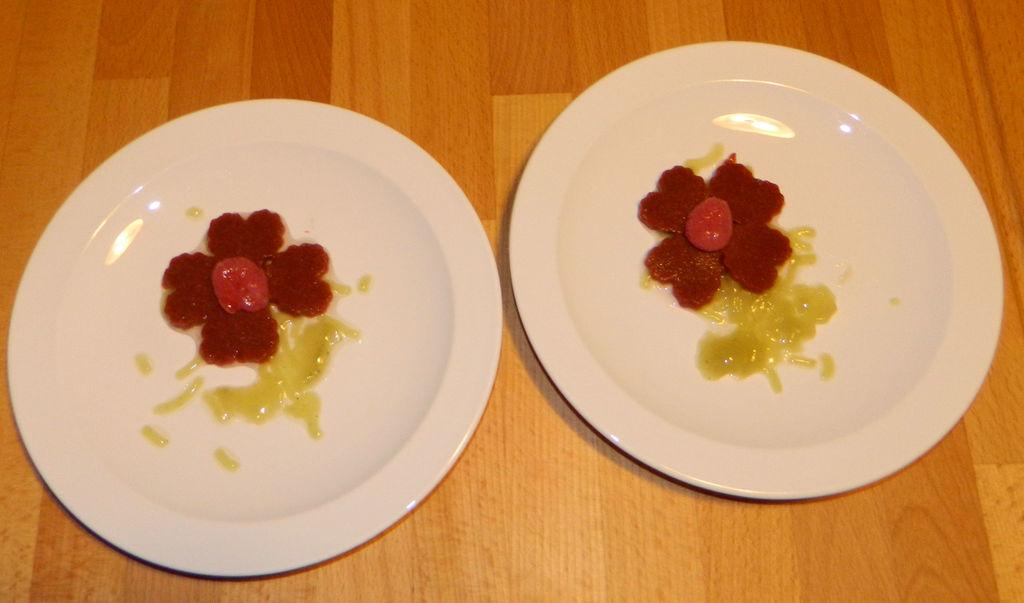What objects are present in the image? The image contains plates and a wooden table. What is unique about the food items on the plates? The food items on the plates are shaped like flowers. What type of wrench can be seen being used to prepare the flower-shaped food items in the image? There is no wrench present in the image, and no food preparation is shown. 